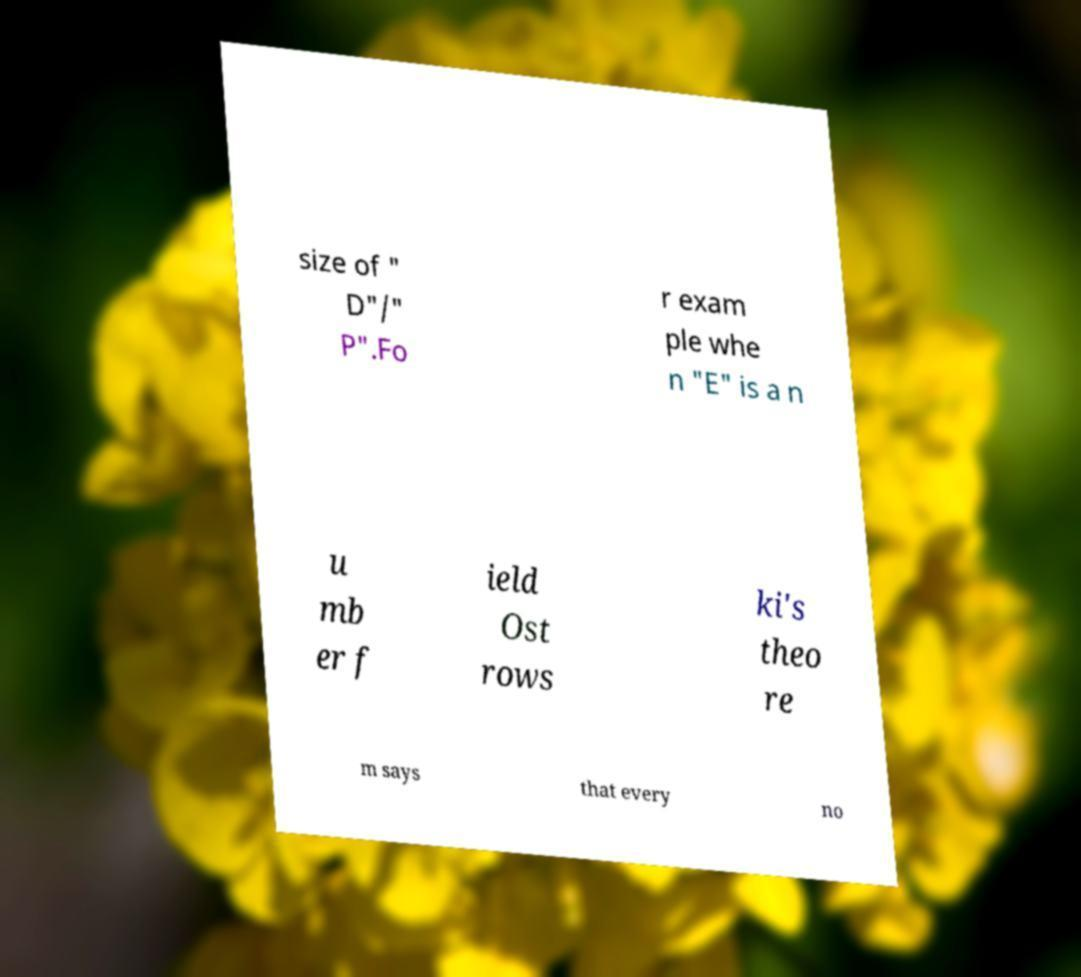For documentation purposes, I need the text within this image transcribed. Could you provide that? size of " D"/" P".Fo r exam ple whe n "E" is a n u mb er f ield Ost rows ki's theo re m says that every no 